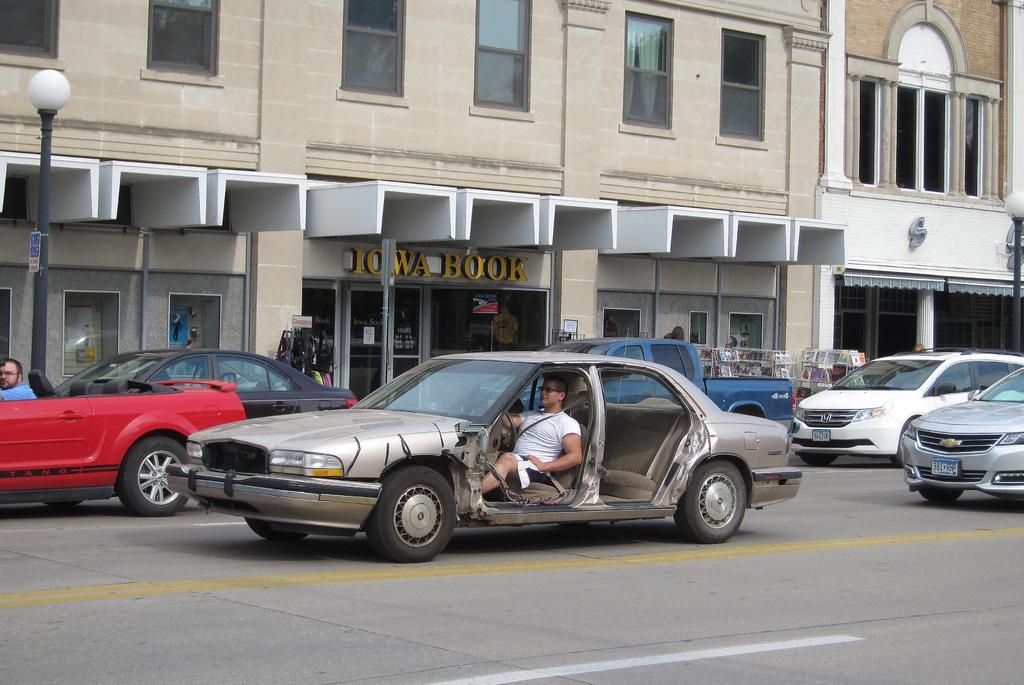In one or two sentences, can you explain what this image depicts? Here we can see vehicles and we can see persons in vehicles. We can see buildings,windows and lights on poles. 